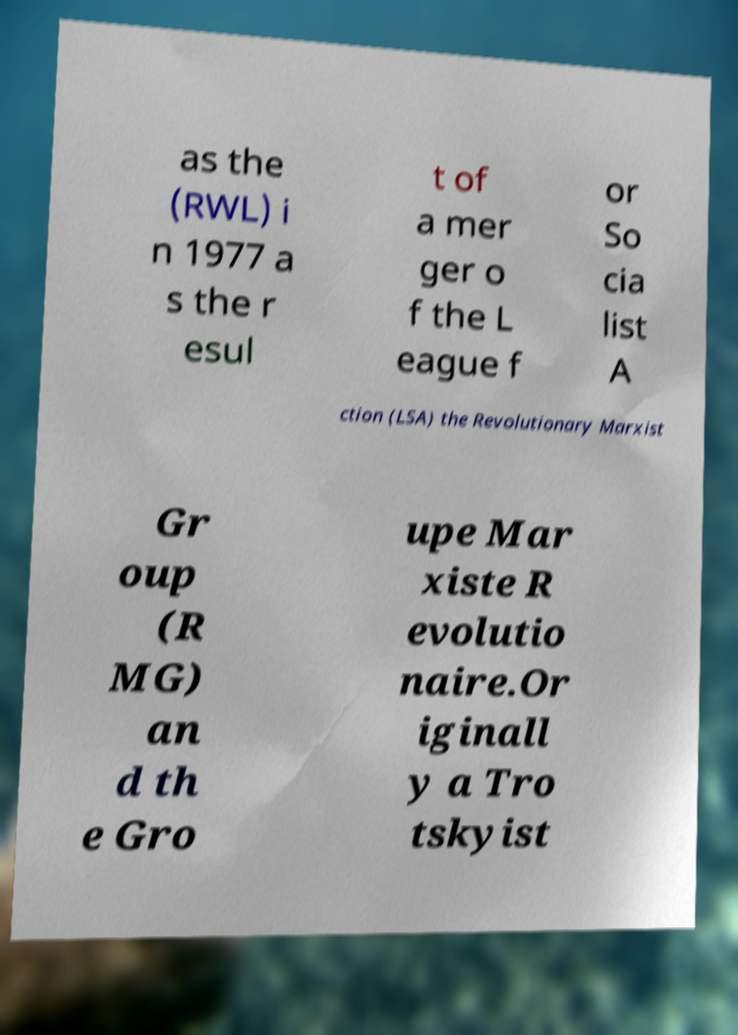Please read and relay the text visible in this image. What does it say? as the (RWL) i n 1977 a s the r esul t of a mer ger o f the L eague f or So cia list A ction (LSA) the Revolutionary Marxist Gr oup (R MG) an d th e Gro upe Mar xiste R evolutio naire.Or iginall y a Tro tskyist 